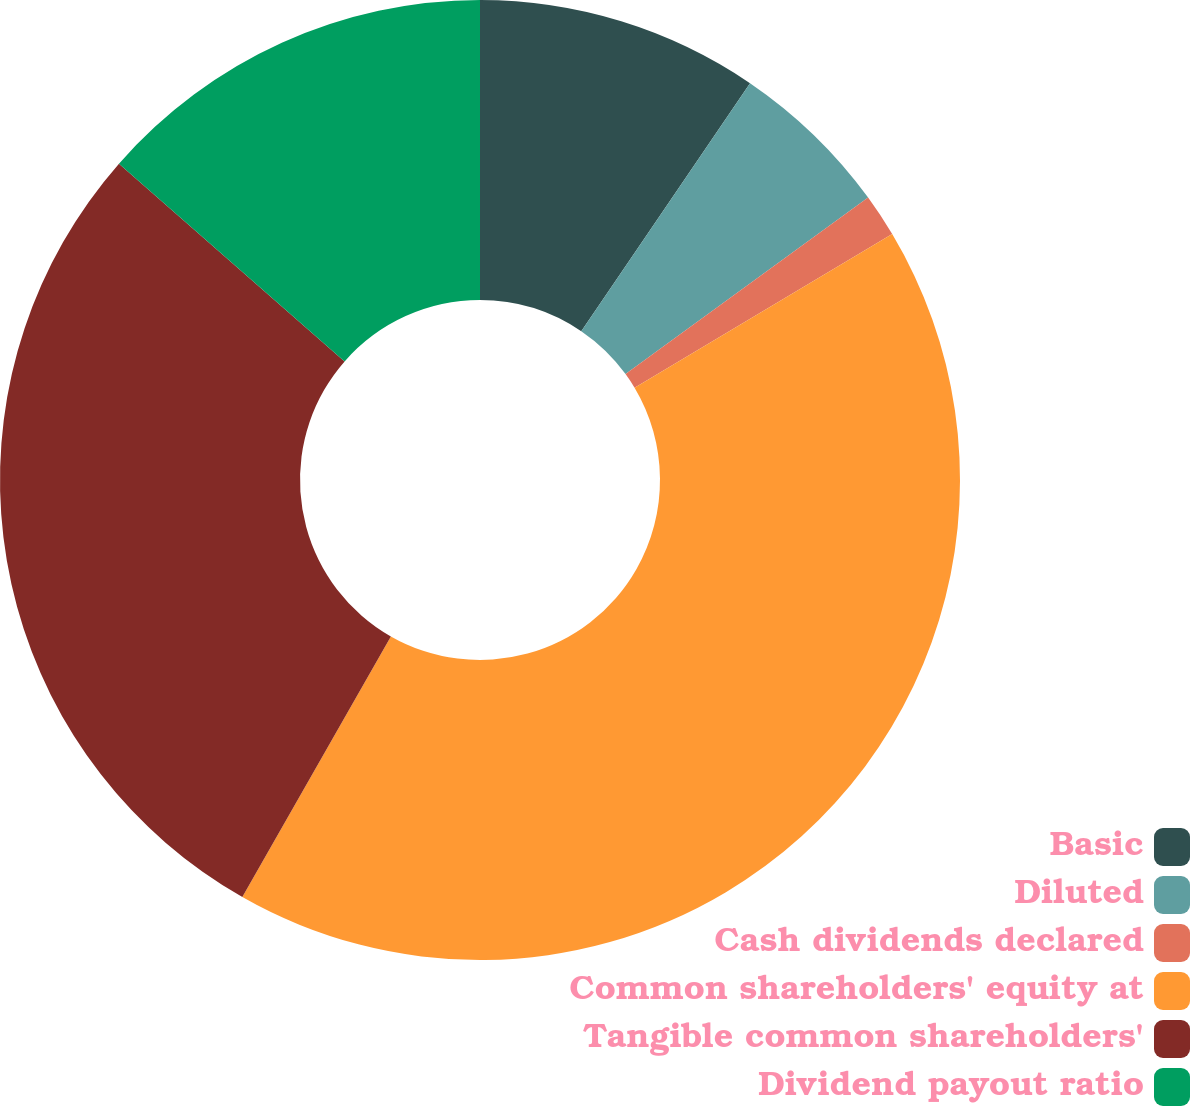Convert chart. <chart><loc_0><loc_0><loc_500><loc_500><pie_chart><fcel>Basic<fcel>Diluted<fcel>Cash dividends declared<fcel>Common shareholders' equity at<fcel>Tangible common shareholders'<fcel>Dividend payout ratio<nl><fcel>9.51%<fcel>5.48%<fcel>1.45%<fcel>41.81%<fcel>28.21%<fcel>13.55%<nl></chart> 